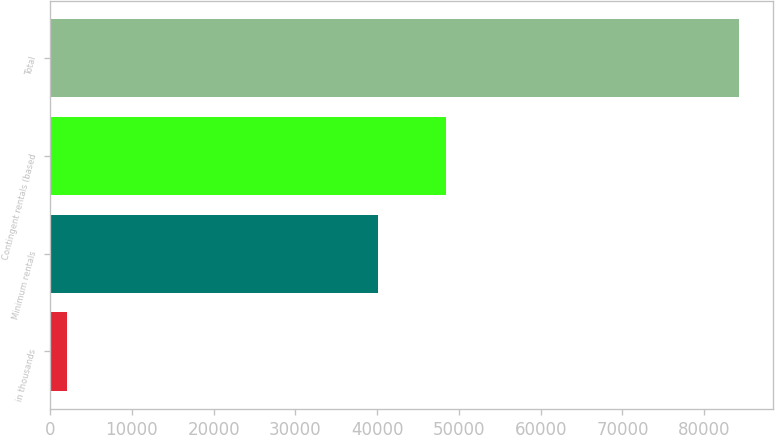<chart> <loc_0><loc_0><loc_500><loc_500><bar_chart><fcel>in thousands<fcel>Minimum rentals<fcel>Contingent rentals (based<fcel>Total<nl><fcel>2013<fcel>40151<fcel>48375.9<fcel>84262<nl></chart> 